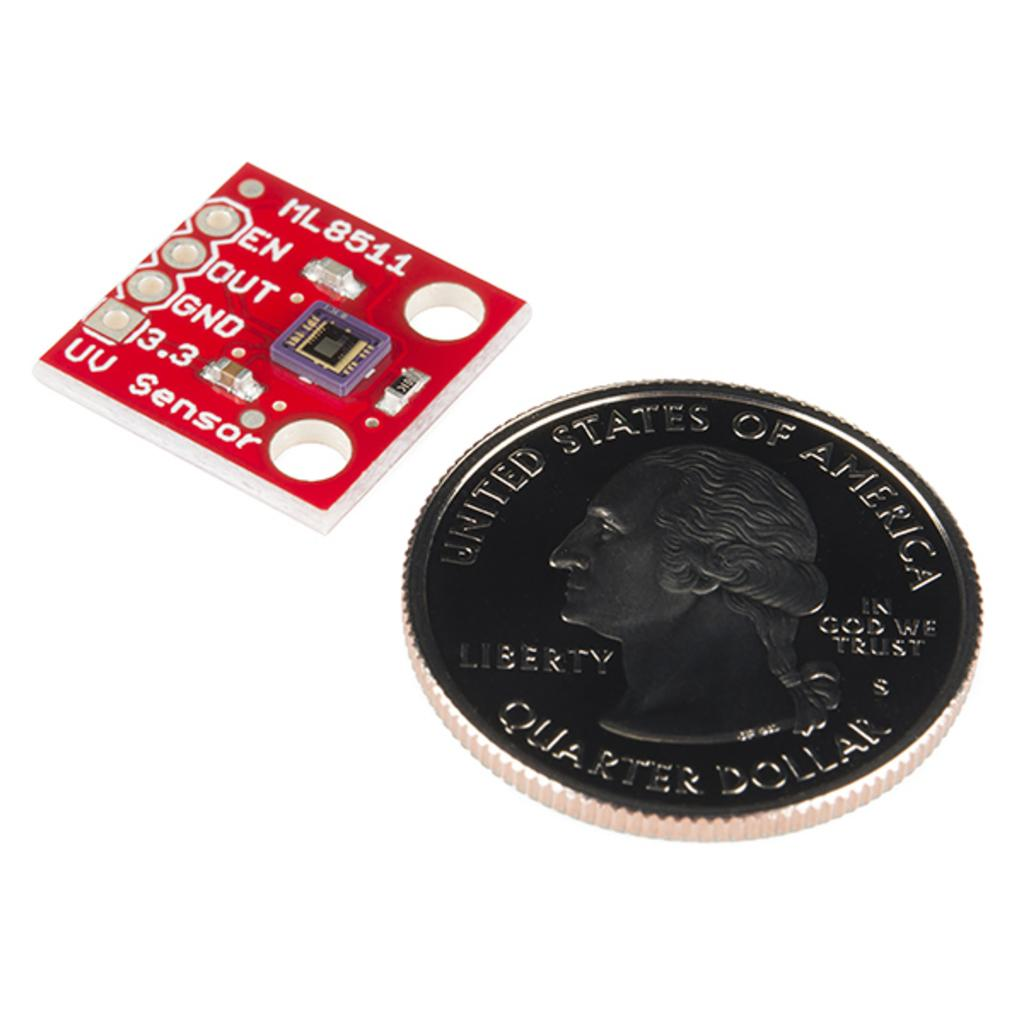<image>
Offer a succinct explanation of the picture presented. Quarter Dollar is etched into the face of this coin. 